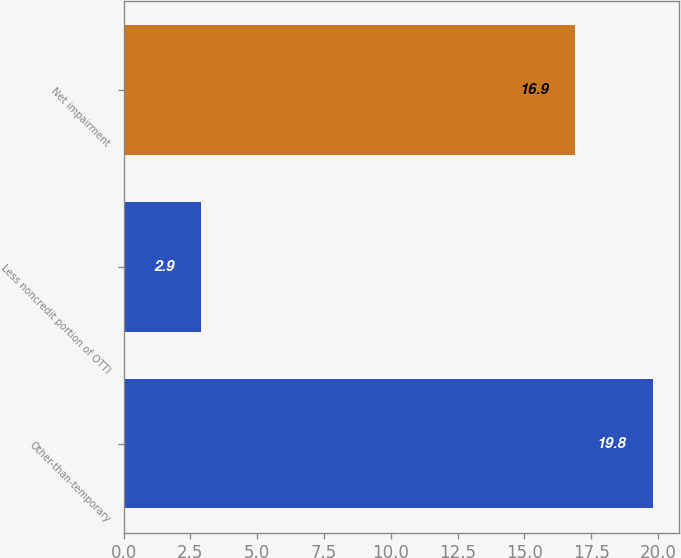<chart> <loc_0><loc_0><loc_500><loc_500><bar_chart><fcel>Other-than-temporary<fcel>Less noncredit portion of OTTI<fcel>Net impairment<nl><fcel>19.8<fcel>2.9<fcel>16.9<nl></chart> 